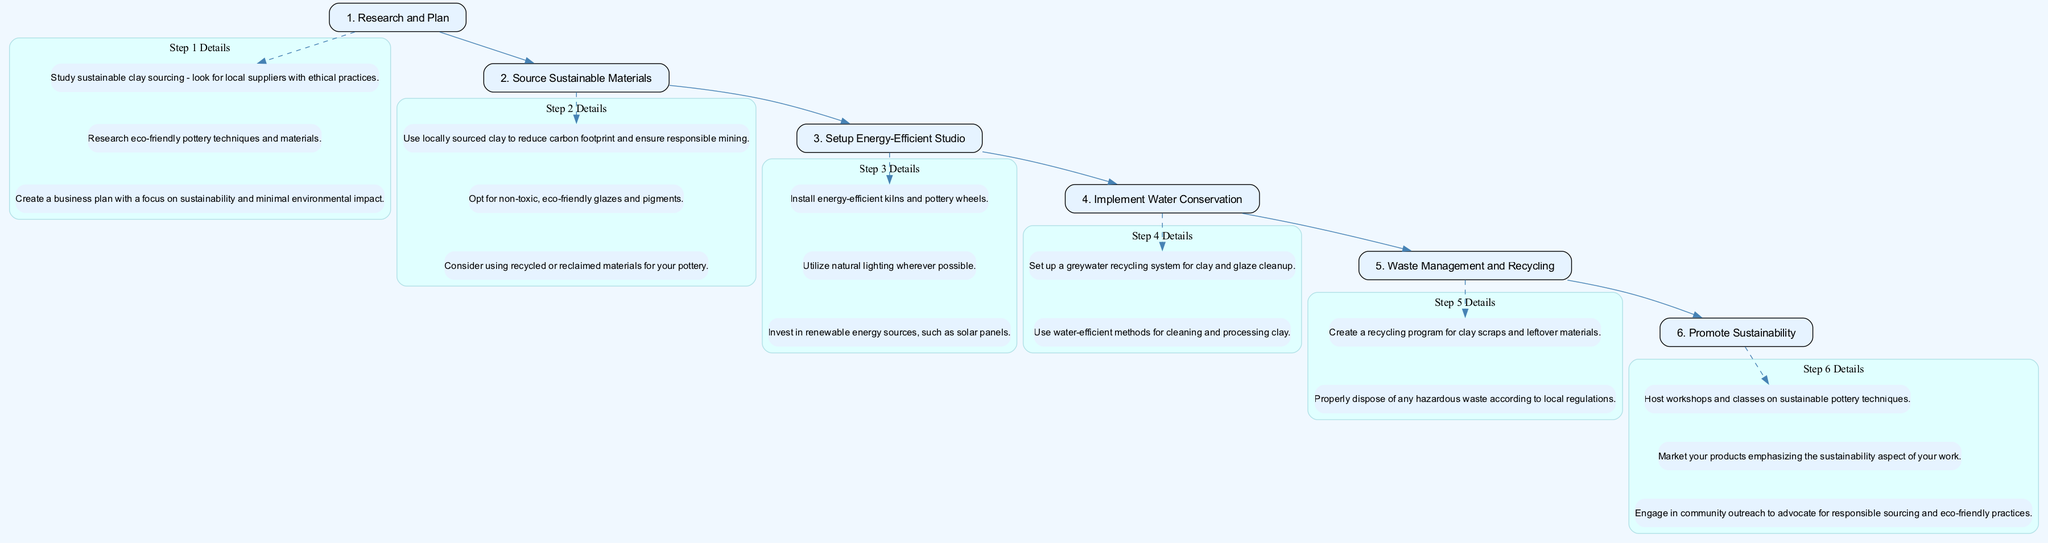What is the first step in setting up a sustainable pottery studio? The first step in the diagram is labeled "Research and Plan," which indicates it is the starting point of the flowchart.
Answer: Research and Plan How many steps are in the diagram? The diagram outlines a total of six steps, which can be counted from the nodes labeled from 1 to 6.
Answer: 6 What is the focus of the "Source Sustainable Materials" step? The node for "Source Sustainable Materials" emphasizes procuring materials that adhere to responsible sourcing and sustainability practices.
Answer: Responsible sourcing and sustainability What follows after "Setup Energy-Efficient Studio"? The next step that follows is "Implement Water Conservation," which can be determined by following the edge connections in the diagram.
Answer: Implement Water Conservation What is the last step in the process? The final step shown in the diagram is labeled "Promote Sustainability," indicating it comes at the end of the instruction flow.
Answer: Promote Sustainability Which step includes details about recycling methods? "Waste Management and Recycling" is the step that provides details related to the establishment of systems for recycling materials in the pottery process.
Answer: Waste Management and Recycling Which step emphasizes the use of local suppliers for clay? The step "Source Sustainable Materials" explicitly discusses the importance of using locally sourced clay to ensure sustainability and minimize environmental impact.
Answer: Source Sustainable Materials How does one promote sustainability according to the last step? The details under "Promote Sustainability" suggest hosting workshops, marketing products for their sustainability aspect, and engaging in community outreach.
Answer: Workshops, marketing, community outreach What strategy is recommended for water conservation? The node's details for "Implement Water Conservation" mention setting up a greywater recycling system as a specific strategy for conserving water during the pottery process.
Answer: Greywater recycling system 